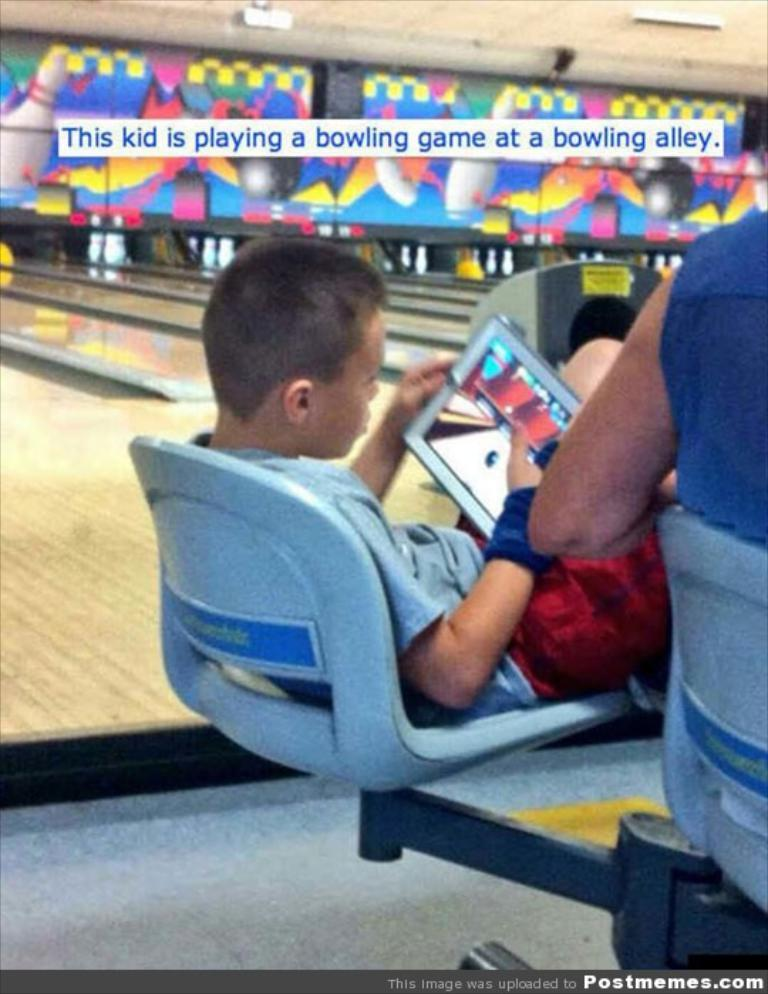<image>
Render a clear and concise summary of the photo. A picture with the caption about the kid playing a bowling game on his device while at a bowling alley. 